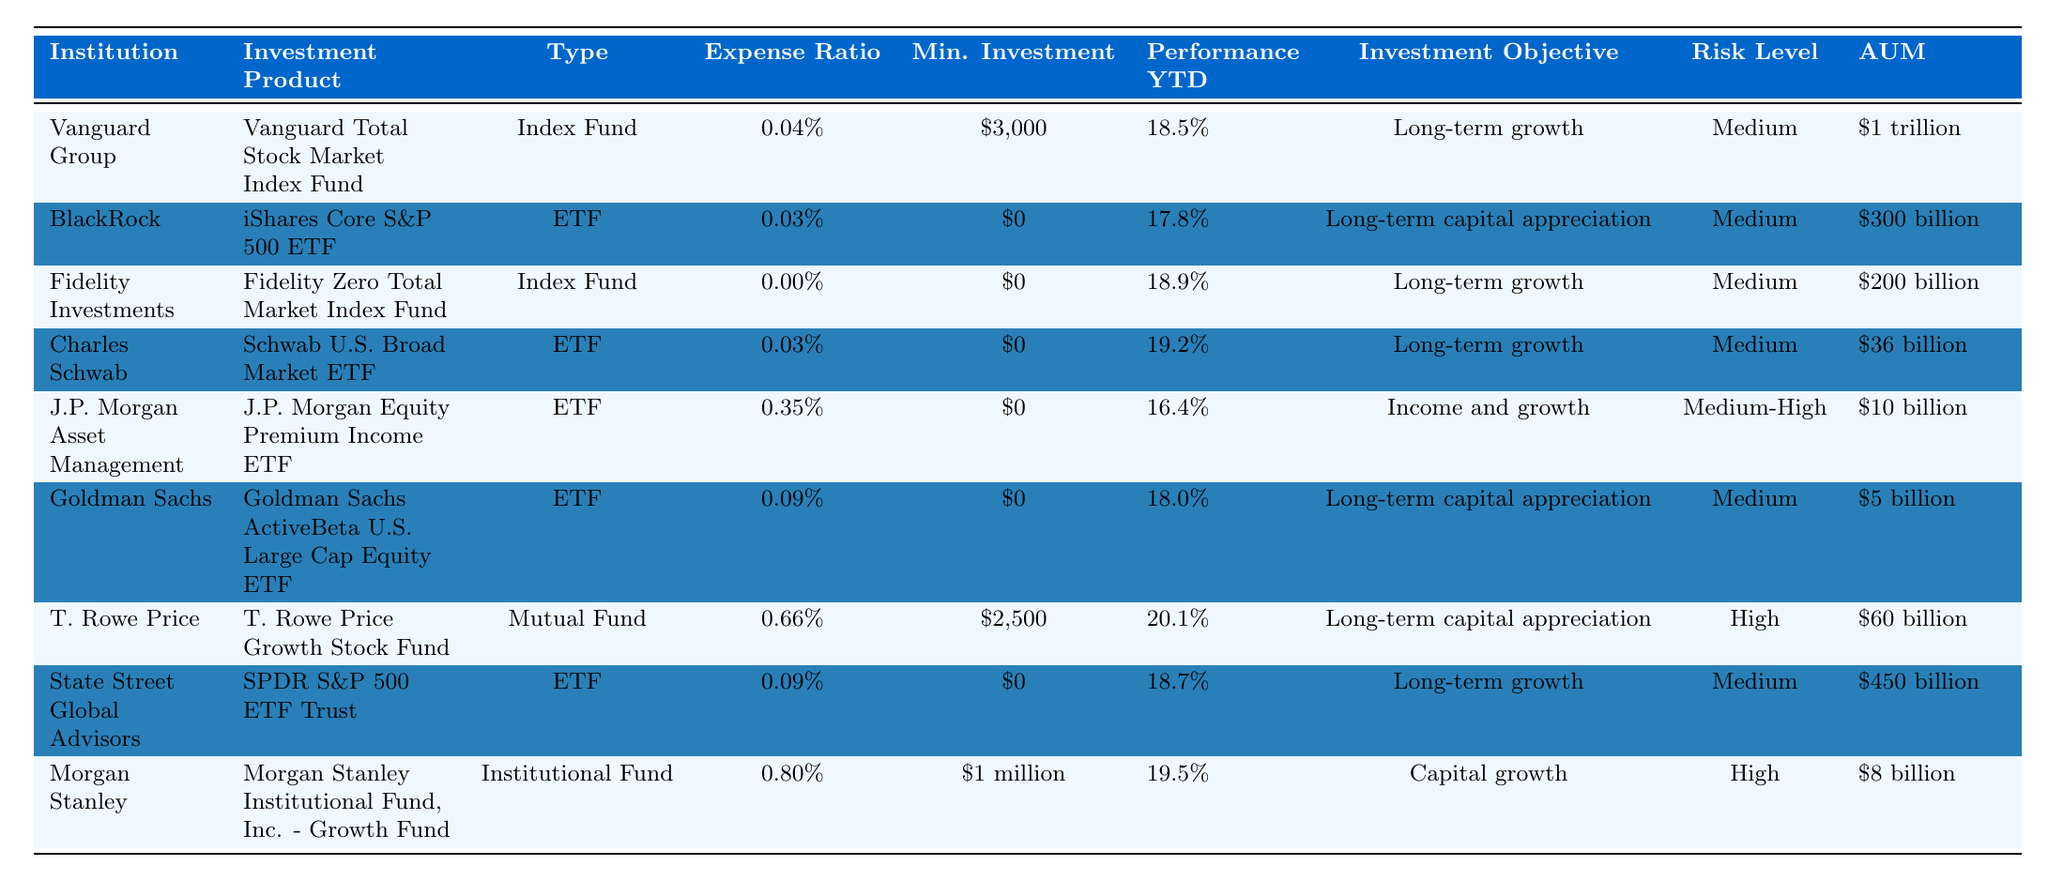What is the expense ratio of the Fidelity Zero Total Market Index Fund? The table shows that the Fidelity Zero Total Market Index Fund has an expense ratio of 0.00%.
Answer: 0.00% Which investment product has the highest performance year-to-date (YTD)? The T. Rowe Price Growth Stock Fund has the highest performance YTD at 20.1%.
Answer: 20.1% How many institutions offer investment products with a minimum investment of $0? Both the iShares Core S&P 500 ETF, Fidelity Zero Total Market Index Fund, Schwab U.S. Broad Market ETF, J.P. Morgan Equity Premium Income ETF, Goldman Sachs ActiveBeta U.S. Large Cap Equity ETF, and SPDR S&P 500 ETF Trust have a minimum investment of $0, totaling six products.
Answer: 6 Is the risk level of Morgan Stanley's investment product classified as high? Yes, the Morgan Stanley Institutional Fund, Inc. - Growth Fund has a risk level classified as high.
Answer: Yes What is the average expense ratio of all the investment products listed? The expense ratios are 0.04%, 0.03%, 0.00%, 0.03%, 0.35%, 0.09%, 0.66%, 0.09%, and 0.80%, leading to a sum of 1.09%. Since there are 9 products, we calculate 1.09% / 9 = 0.1211%, or approximately 0.12%.
Answer: 0.12% Which investment product has the lowest assets under management (AUM)? The Goldman Sachs ActiveBeta U.S. Large Cap Equity ETF has the lowest AUM at $5 billion, compared to all other investment products listed.
Answer: $5 billion How does the performance YTD of the Charles Schwab ETF compare to the average performance YTD of all listed investment products? The performance YTD of the Charles Schwab ETF is 19.2%. The average performance can be calculated as (18.5% + 17.8% + 18.9% + 19.2% + 16.4% + 18.0% + 20.1% + 18.7% + 19.5%) / 9, which is approximately 18.5%. Since 19.2% is greater than the average, it is better by 0.7%.
Answer: Better than average Which institution has the highest assets under management (AUM) and what is that value? Vanguard Group has the highest AUM listed at $1 trillion.
Answer: $1 trillion What is the total minimum investment required for T. Rowe Price and Morgan Stanley's products? The minimum investment for T. Rowe Price is $2,500, and for Morgan Stanley, it is $1 million. Therefore, the total minimum investment is $2,500 + $1,000,000 = $1,002,500.
Answer: $1,002,500 Does the Vanguard Total Stock Market Index Fund and Fidelity Zero Total Market Index Fund have the same investment objective? Yes, both have the investment objective of long-term growth.
Answer: Yes 